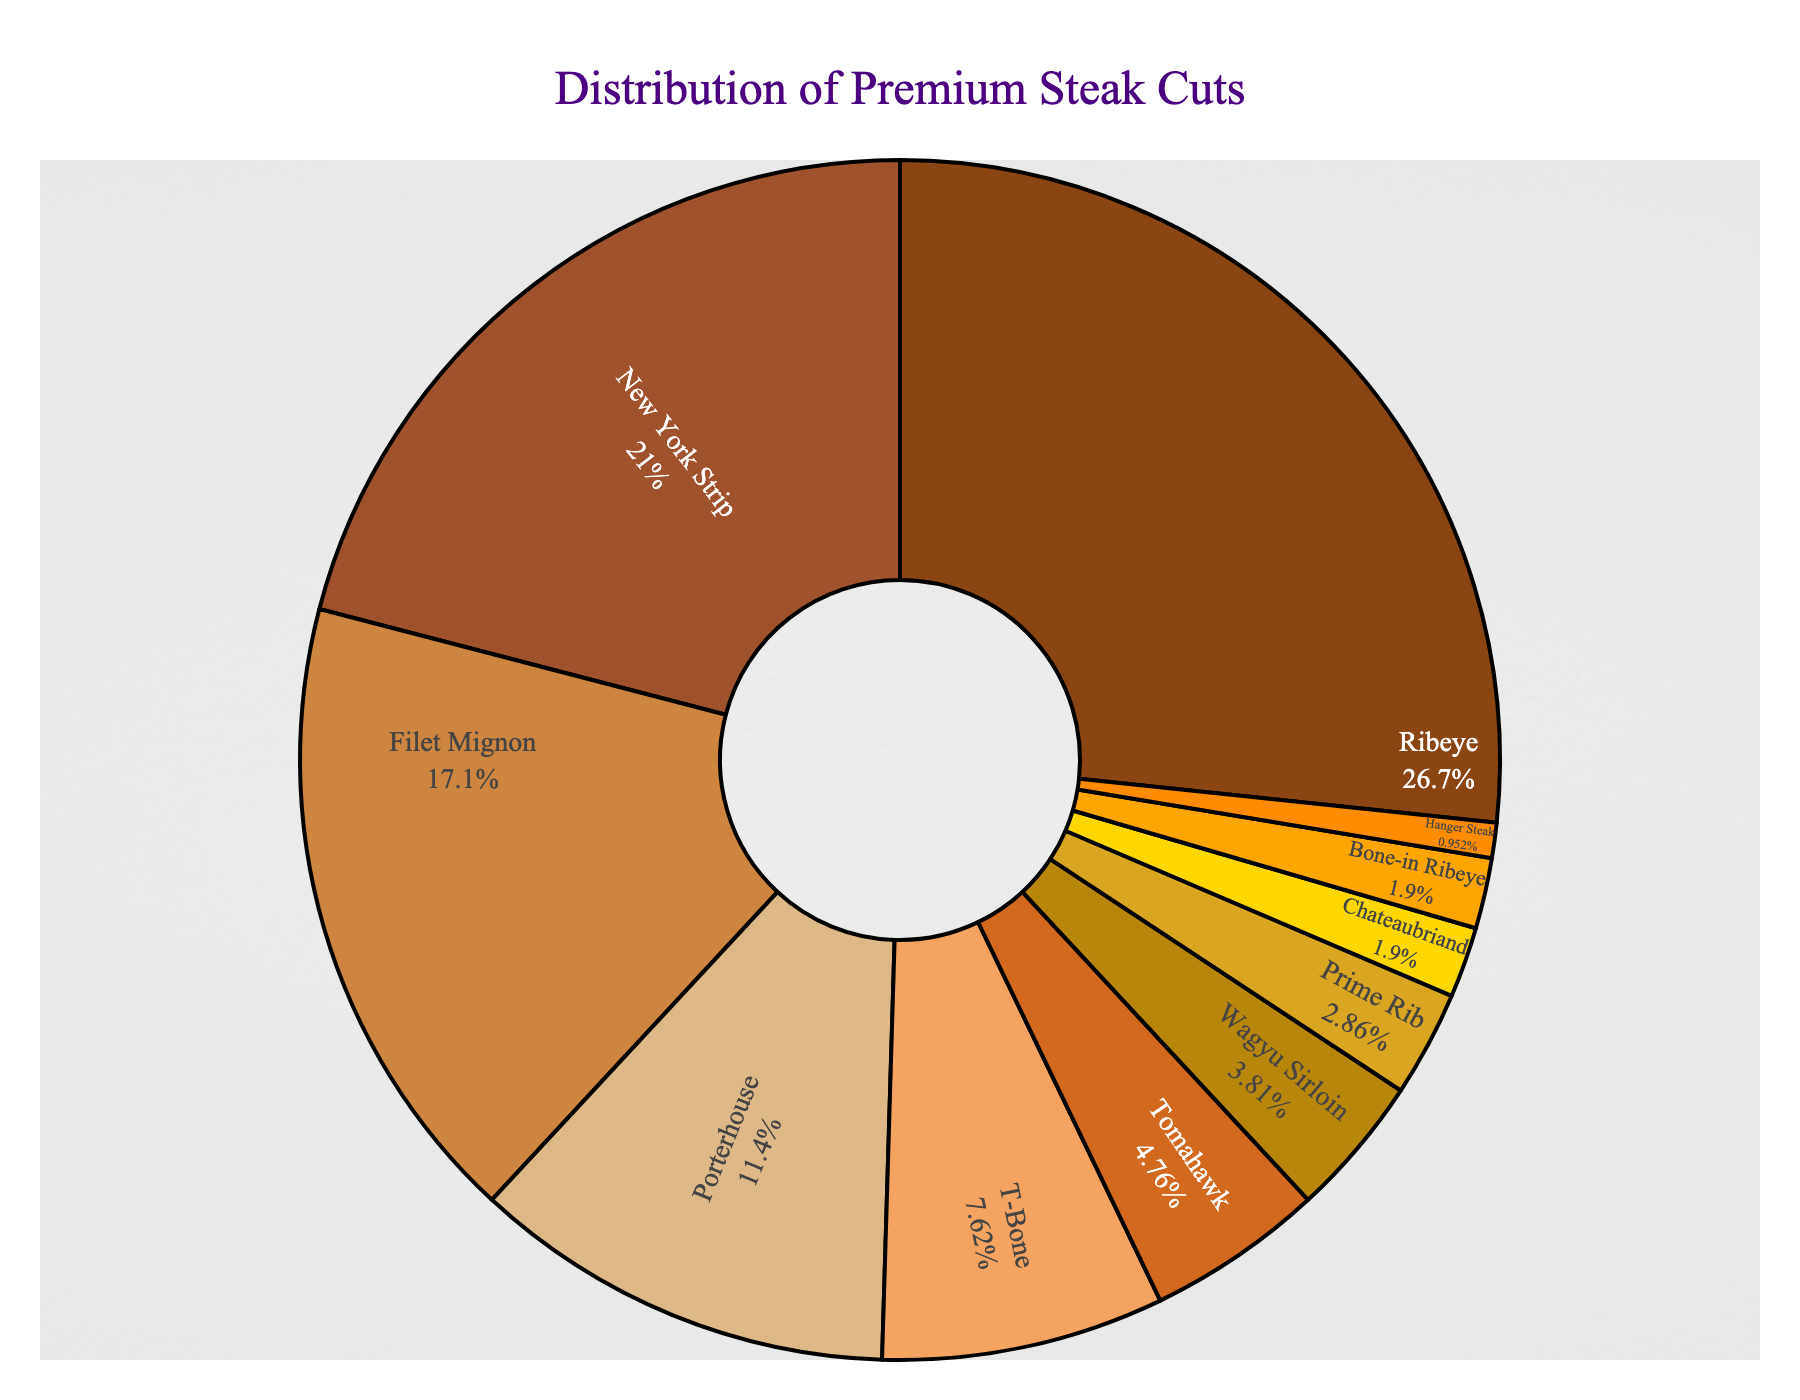Which steak cut is the most ordered? The Ribeye steak has the highest percentage among all the steak cuts, which makes it the most ordered cut.
Answer: Ribeye Which two steak cuts have the lowest demand? The two steak cuts with the lowest demand are the Chateaubriand and the Bone-in Ribeye, each with a percentage of 2%.
Answer: Chateaubriand and Bone-in Ribeye How much more common is the Ribeye compared to the Wagyu Sirloin? The Ribeye is ordered 28% of the time, while the Wagyu Sirloin is ordered 4% of the time. The difference is 28% - 4% = 24%, so the Ribeye is 24% more common.
Answer: 24% What is the combined percentage of orders for the Porterhouse and T-Bone steaks? The Porterhouse makes up 12% and the T-Bone makes up 8%. Combined, they account for 12% + 8% = 20% of the orders.
Answer: 20% Which cut is ordered exactly half as often as the Ribeye? The New York Strip has an ordering percentage of 22%, which is less than half of the Ribeye's 28%. The Filet Mignon, with 18%, is close, but no cut is exactly half as often as the Ribeye's 28%.
Answer: None What is the percentage difference between the New York Strip and Filet Mignon? The New York Strip is ordered 22% of the time and the Filet Mignon is ordered 18% of the time. The percentage difference is 22% - 18% = 4%.
Answer: 4% Which steak cut is represented by a dark brown color in the chart? The Ribeye is represented by the darkest brown color in the chart.
Answer: Ribeye If you combine the percentages of Filet Mignon, T-Bone, and Wagyu Sirloin, do they surpass the percentage of Ribeye? Filet Mignon is 18%, T-Bone is 8%, and Wagyu Sirloin is 4%. Their combined percentage is 18% + 8% + 4% = 30%, which surpasses the Ribeye's 28%.
Answer: Yes Which cut between the Porterhouse and Tomahawk has higher orders? The Porterhouse steak has 12%, while the Tomahawk has 5%. Therefore, the Porterhouse has higher orders.
Answer: Porterhouse If you combine all cuts that are ordered 5% or less, what is the total percentage? Tomahawk at 5%, Wagyu Sirloin at 4%, Prime Rib at 3%, Chateaubriand at 2%, Bone-in Ribeye at 2%, and Hanger Steak at 1%. Combined, 5% + 4% + 3% + 2% + 2% + 1% = 17%.
Answer: 17% 